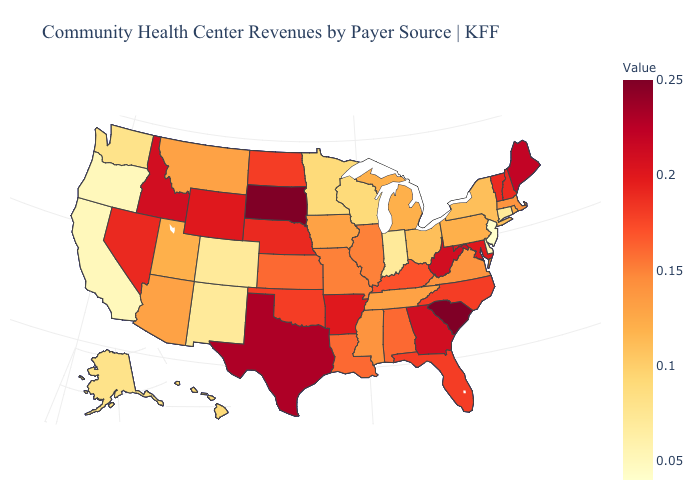Among the states that border New Hampshire , which have the lowest value?
Give a very brief answer. Massachusetts. Does Connecticut have a lower value than New Jersey?
Short answer required. No. Does the map have missing data?
Give a very brief answer. No. Among the states that border Vermont , does New York have the highest value?
Quick response, please. No. Does Alaska have a higher value than New Jersey?
Write a very short answer. Yes. Among the states that border Minnesota , does North Dakota have the lowest value?
Be succinct. No. 